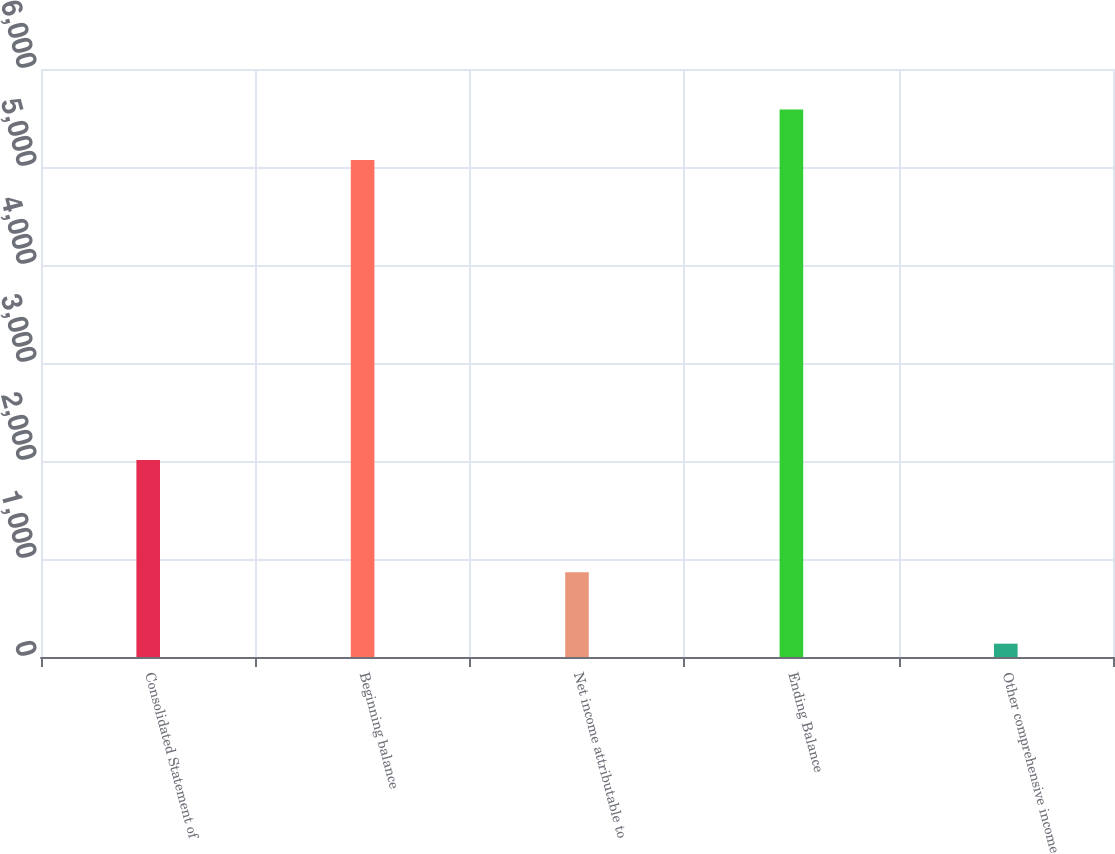Convert chart. <chart><loc_0><loc_0><loc_500><loc_500><bar_chart><fcel>Consolidated Statement of<fcel>Beginning balance<fcel>Net income attributable to<fcel>Ending Balance<fcel>Other comprehensive income<nl><fcel>2011<fcel>5071<fcel>866<fcel>5587.9<fcel>136<nl></chart> 